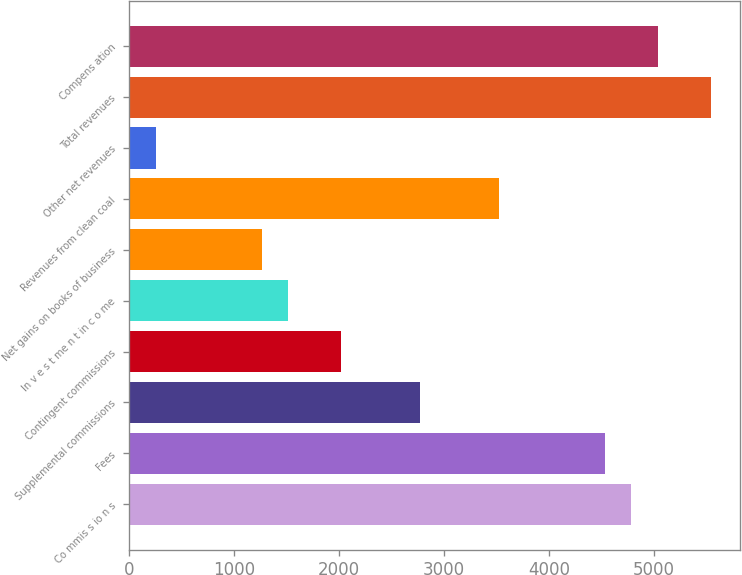Convert chart. <chart><loc_0><loc_0><loc_500><loc_500><bar_chart><fcel>Co mmis s io n s<fcel>Fees<fcel>Supplemental commissions<fcel>Contingent commissions<fcel>In v e s t me n t in c o me<fcel>Net gains on books of business<fcel>Revenues from clean coal<fcel>Other net revenues<fcel>Total revenues<fcel>Compens ation<nl><fcel>4787.27<fcel>4535.38<fcel>2772.15<fcel>2016.48<fcel>1512.7<fcel>1260.81<fcel>3527.82<fcel>253.25<fcel>5542.94<fcel>5039.16<nl></chart> 